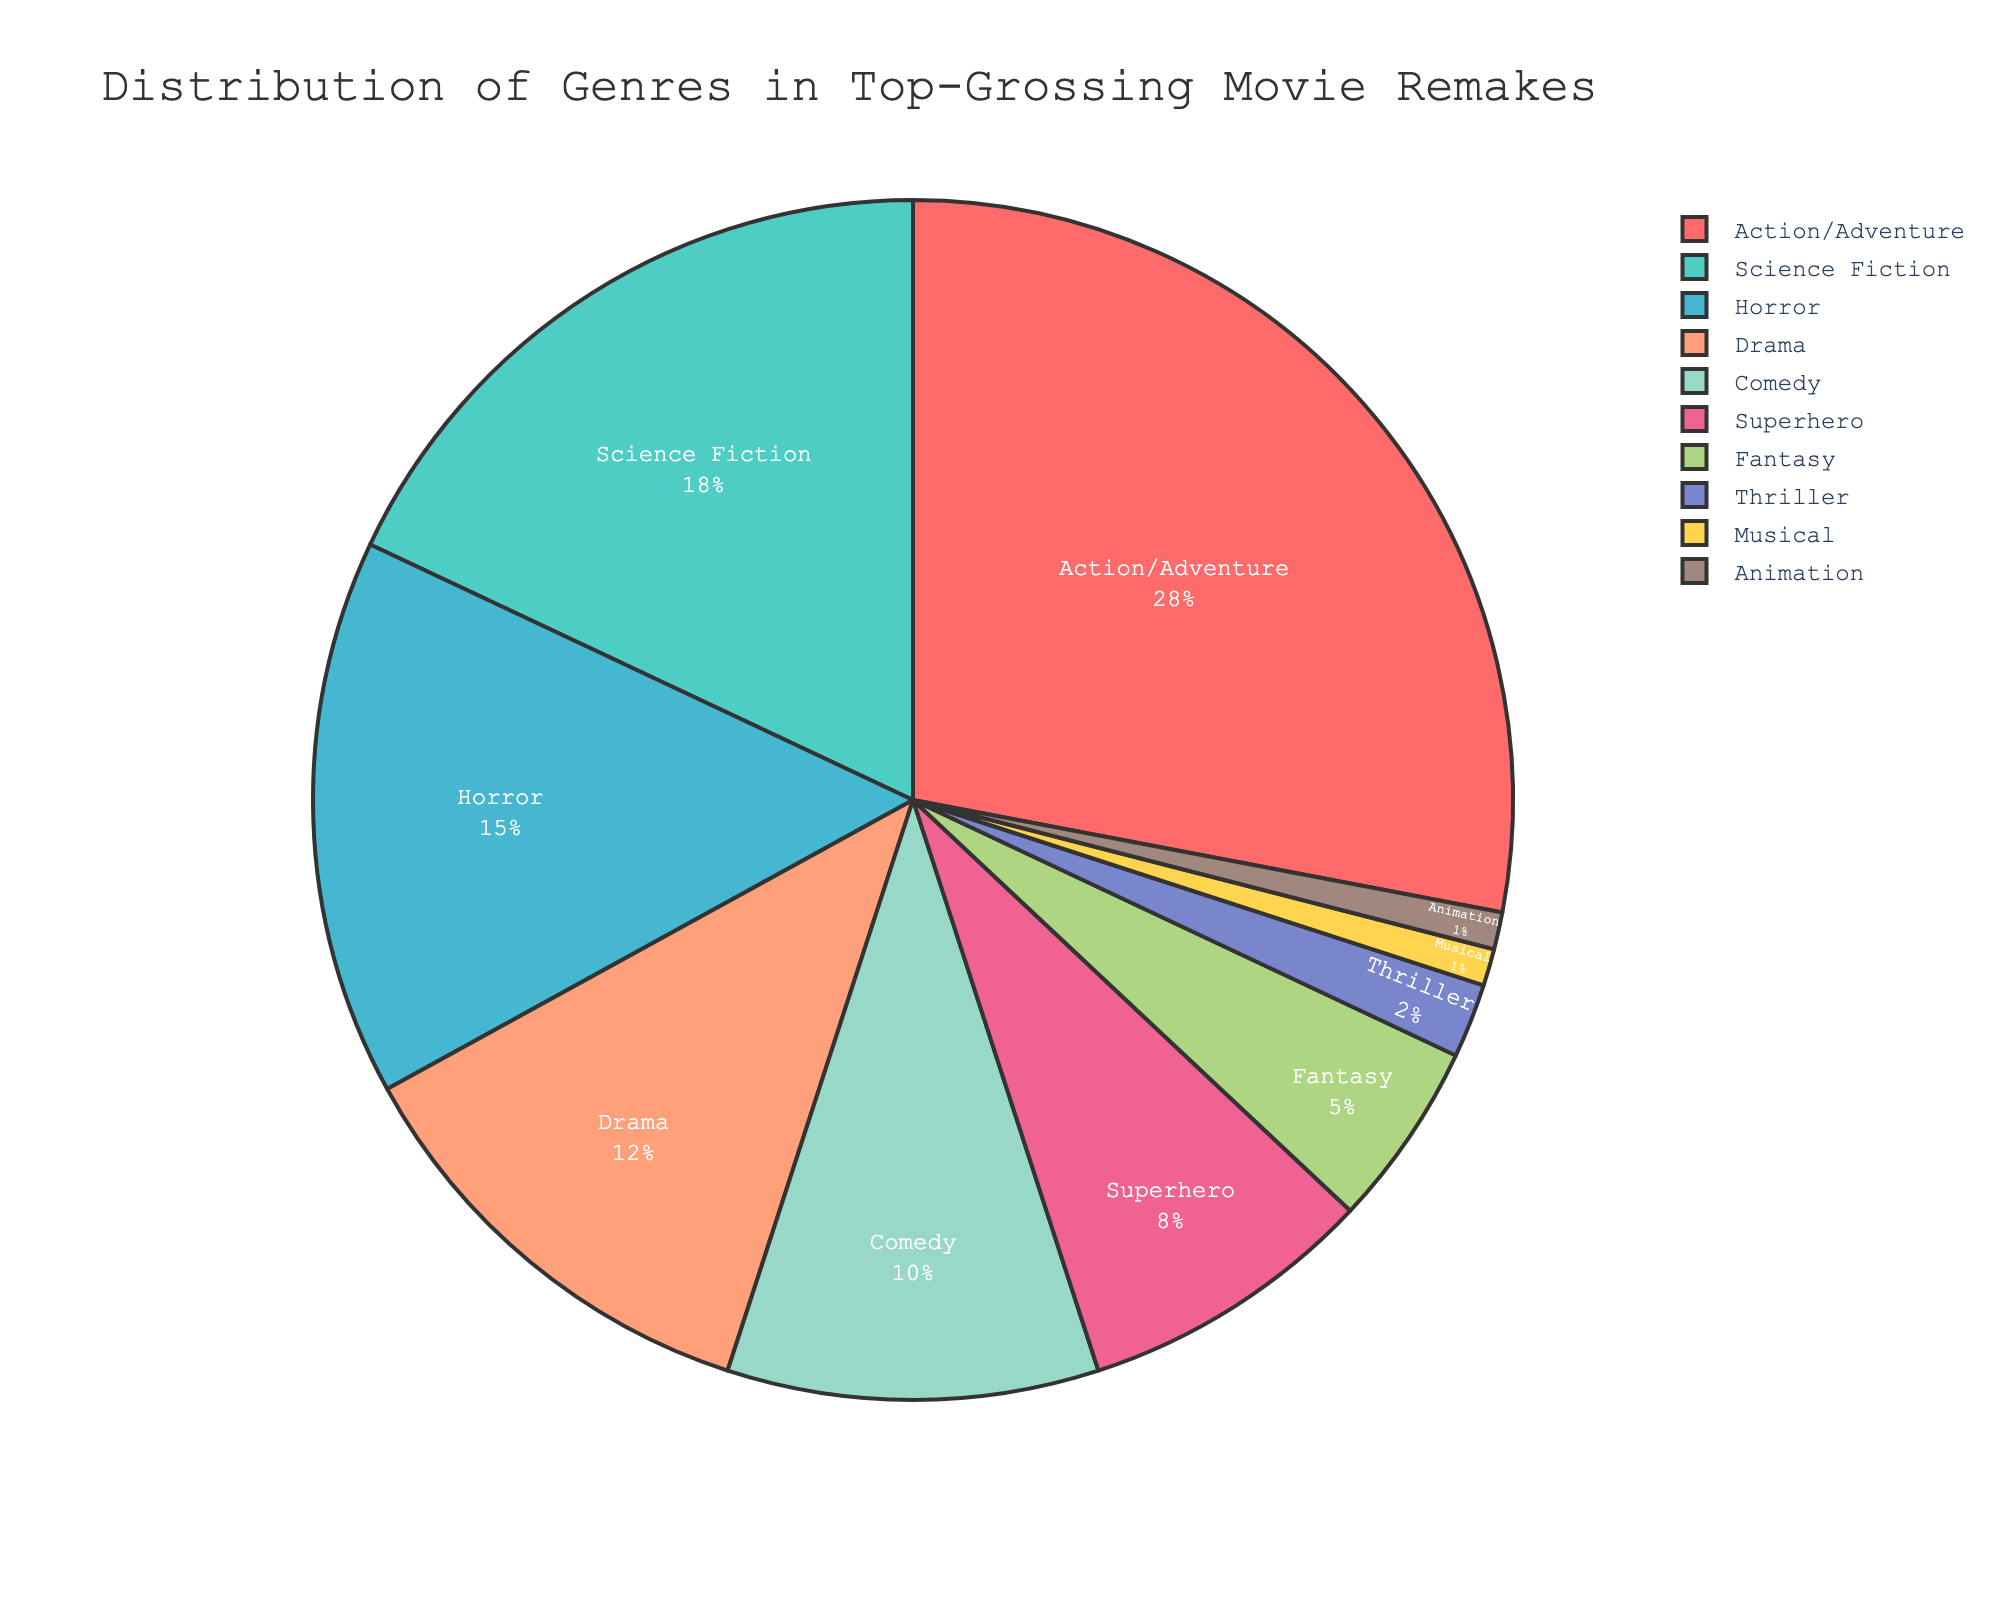What genre has the highest percentage in top-grossing movie remakes? By looking at the pie chart, the genre with the largest segment will indicate the highest percentage.
Answer: Action/Adventure Which genres together constitute more than 50% of the distribution? Considering the largest segments first, we can sum the percentages until we exceed 50%. Action/Adventure (28%) + Science Fiction (18%) = 46%, adding Horror (15%) gives us 61%, which is more than 50%.
Answer: Action/Adventure, Science Fiction, Horror What is the percentage difference between Action/Adventure and Science Fiction genres? Subtract the percentage of Science Fiction from that of Action/Adventure: 28% - 18% = 10%.
Answer: 10% Which genre has the least percentage and what is it? The smallest segment in the pie chart will show which genre has the least percentage.
Answer: Animation, Musical (tie) How many genres have a percentage higher than 10%? By examining the segments of the pie chart, count the number of genres with percentages greater than 10%. Action/Adventure (28%), Science Fiction (18%), Horror (15%), and Drama (12%) are higher than 10%.
Answer: 4 What's the combined percentage of Comedy and Superhero genres? Add the percentages of Comedy and Superhero: 10% (Comedy) + 8% (Superhero) = 18%.
Answer: 18% Which genres have a percentage between 5% and 15%, inclusive? Look at the segments and identify the ones that fall between 5% and 15%. Horror (15%), Comedy (10%), and Superhero (8%) match the criteria.
Answer: Horror, Comedy, Superhero Compare the total percentage of genres with less than 5% to those greater than 15%. Which is larger and by how much? Add the percentages of genres less than 5%: Fantasy (5%) + Thriller (2%) + Musical (1%) + Animation (1%) = 9%. Add the genres greater than 15%: Action/Adventure (28%) + Science Fiction (18%) + Horror (15%) = 61%. Now, subtract the totals: 61% - 9% = 52%.
Answer: Greater than 15% genres by 52% What's the average percentage of genres listed? Sum all genre percentages and divide by the total number of genres: (28 + 18 + 15 + 12 + 10 + 8 + 5 + 2 + 1 + 1) / 10 = 10%.
Answer: 10% Are there any genres with equal percentages? If so, which ones? By looking at the pie chart segments, we see that both Musical and Animation have the same percentage of 1%.
Answer: Musical, Animation 